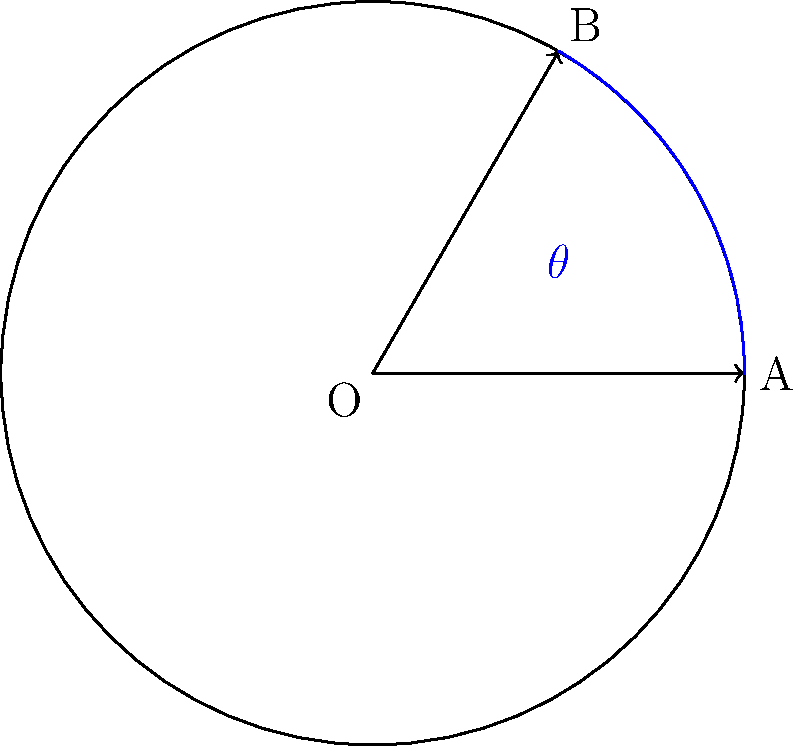In your latest video game-inspired artwork, you're designing a circular power-up icon that rotates on the screen. The icon starts at point A and rotates counterclockwise to point B as shown in the diagram. If the angle of rotation $\theta$ is 60°, what is the length of the arc AB in terms of $\pi$ and the radius $r$ of the circle? To find the length of the arc AB, we can follow these steps:

1) First, recall the formula for arc length:
   Arc length = $\frac{\theta}{360°} \cdot 2\pi r$
   where $\theta$ is the central angle in degrees, and $r$ is the radius of the circle.

2) We are given that the angle of rotation $\theta$ is 60°.

3) Substituting these values into the formula:
   Arc length = $\frac{60°}{360°} \cdot 2\pi r$

4) Simplify the fraction:
   Arc length = $\frac{1}{6} \cdot 2\pi r$

5) Simplify further:
   Arc length = $\frac{\pi r}{3}$

Therefore, the length of the arc AB is $\frac{\pi r}{3}$.
Answer: $\frac{\pi r}{3}$ 